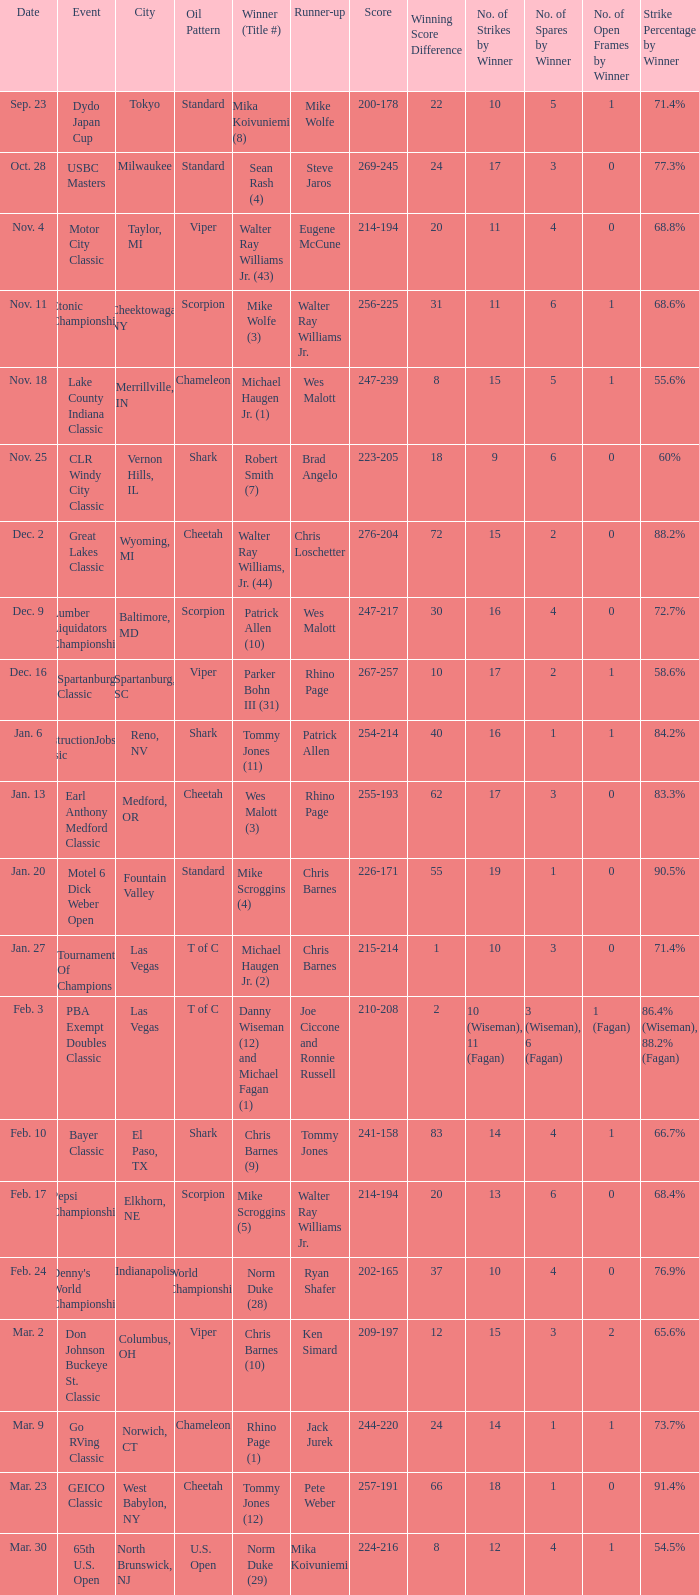Name the Event which has a Score of 209-197? Don Johnson Buckeye St. Classic. 